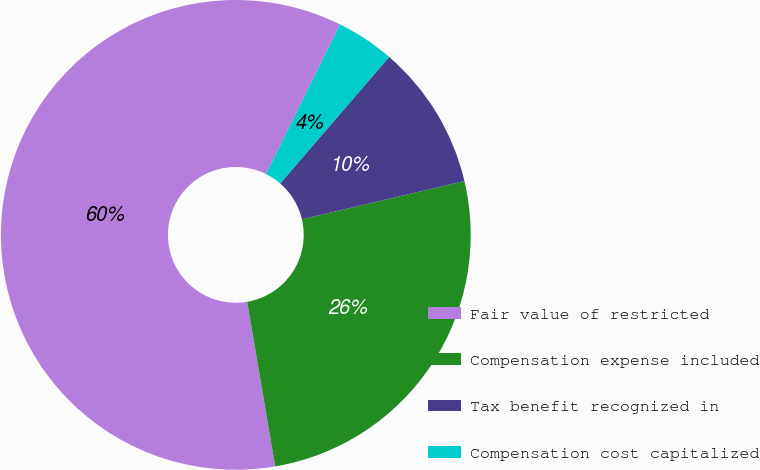<chart> <loc_0><loc_0><loc_500><loc_500><pie_chart><fcel>Fair value of restricted<fcel>Compensation expense included<fcel>Tax benefit recognized in<fcel>Compensation cost capitalized<nl><fcel>60.0%<fcel>26.0%<fcel>10.0%<fcel>4.0%<nl></chart> 